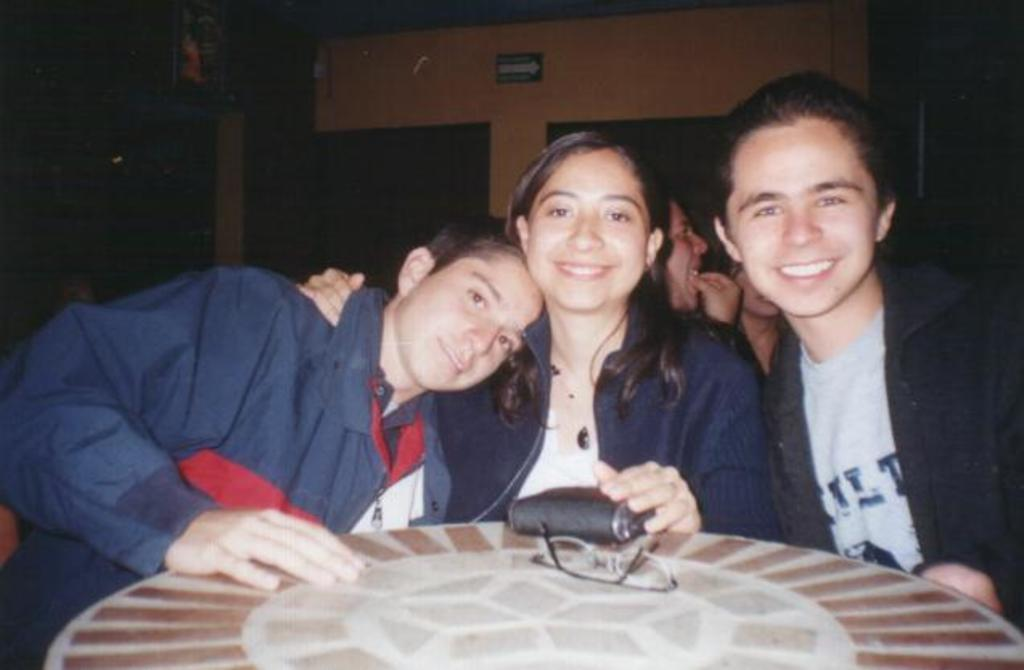What is present in the image? There are people in the image. Can you describe the expressions on the people's faces? The people have smiles on their faces. What type of gun can be seen in the image? There is no gun present in the image. Can you describe the time of day in the image? The time of day cannot be determined from the image, as there is no reference to lighting or time-specific elements. 